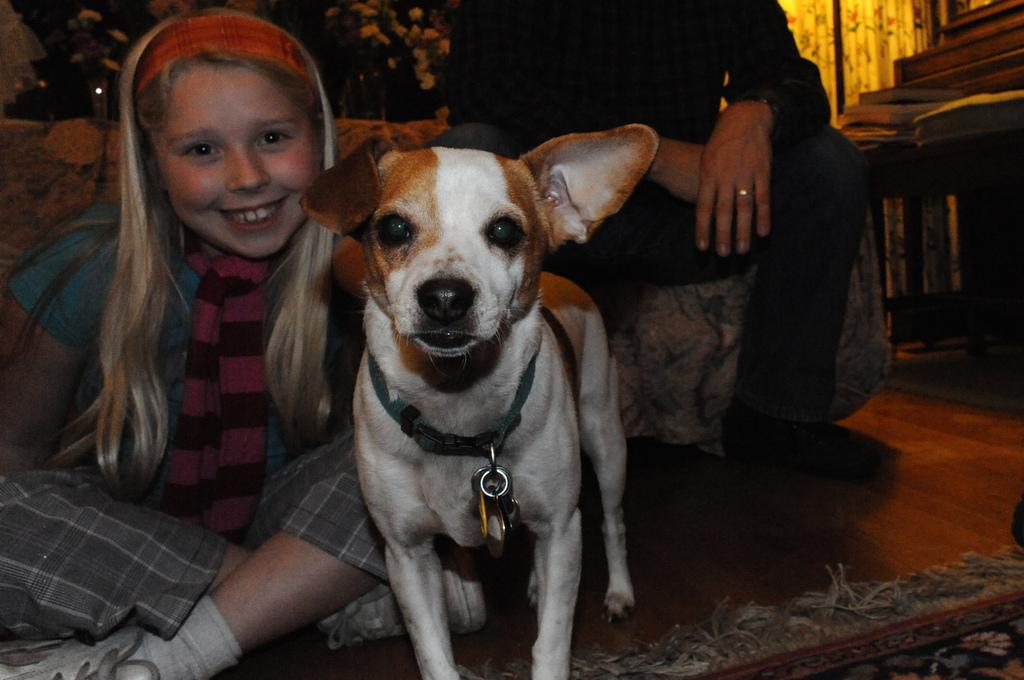What is the girl doing in the image? The girl is sitting on the floor on the left side of the image. What can be seen in the middle of the image? There is a dog in the middle of the image. Can you describe the dog's appearance? The dog is white and brown in color. What is the person on the right side of the image doing? The person is sitting on a sofa on the right side of the image. Is the dog in jail in the image? No, there is no jail present in the image, and the dog is not depicted as being in jail. What type of gold object is visible in the image? There is no gold object present in the image. 